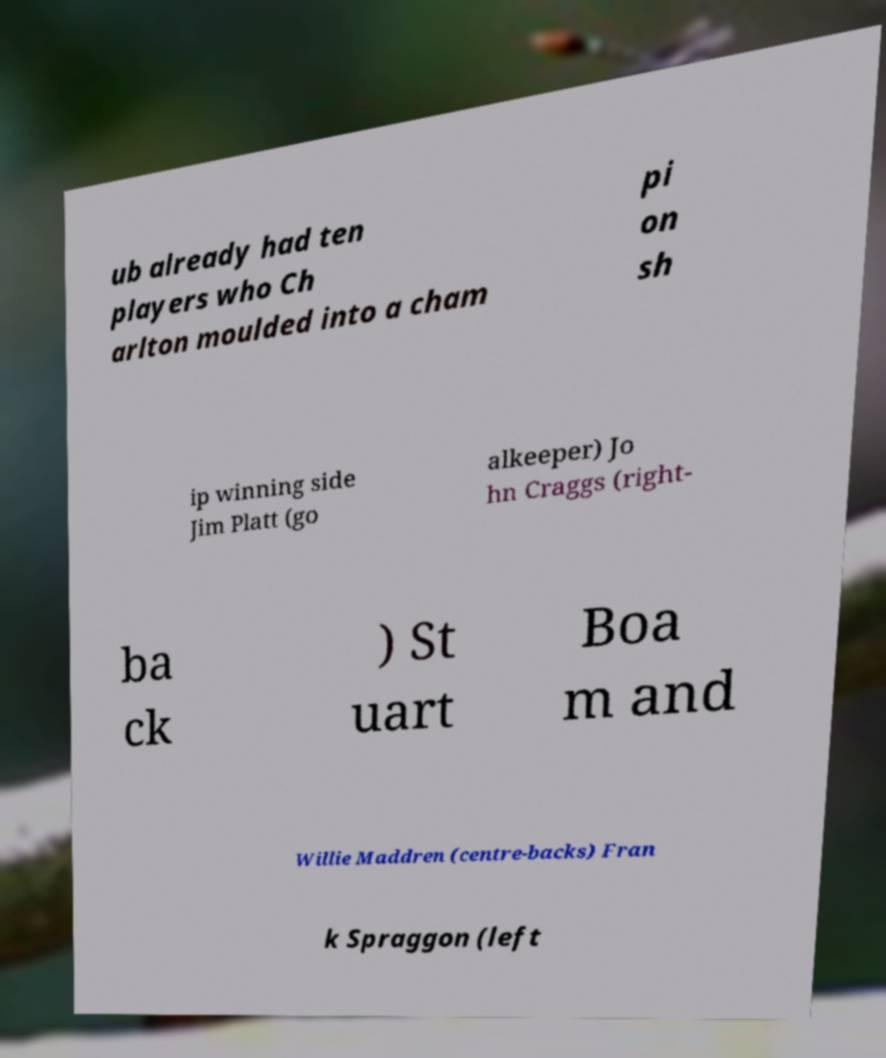Can you read and provide the text displayed in the image?This photo seems to have some interesting text. Can you extract and type it out for me? ub already had ten players who Ch arlton moulded into a cham pi on sh ip winning side Jim Platt (go alkeeper) Jo hn Craggs (right- ba ck ) St uart Boa m and Willie Maddren (centre-backs) Fran k Spraggon (left 